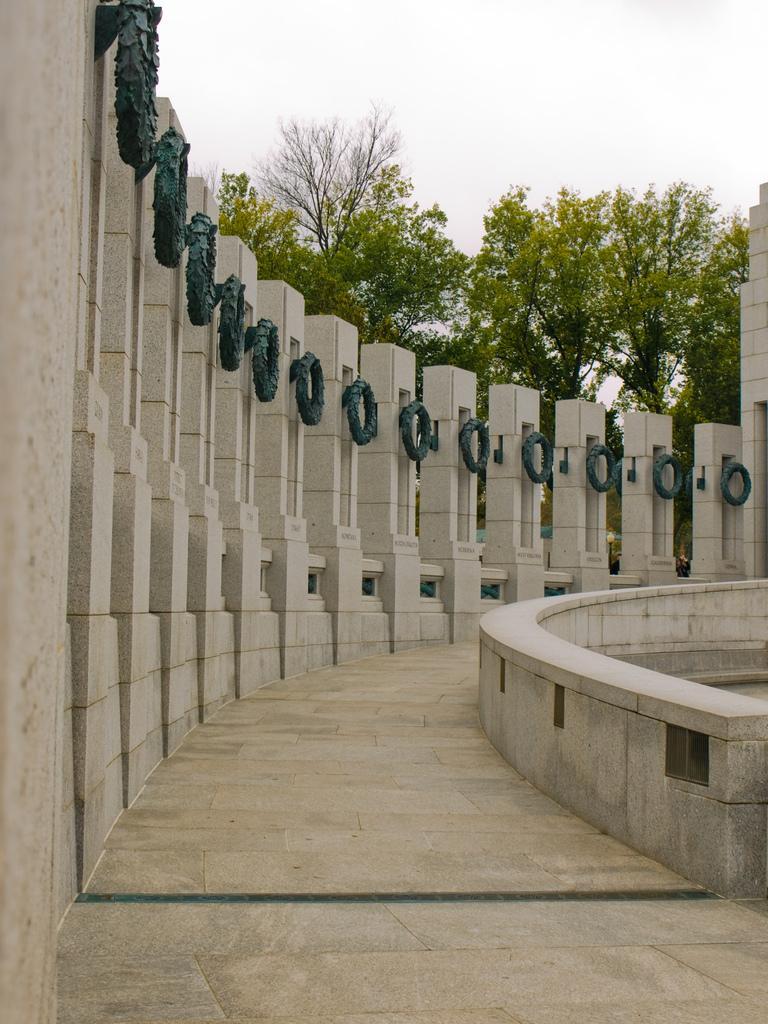Could you give a brief overview of what you see in this image? This image consists of some building. There are trees in the middle. There is sky at the top. 